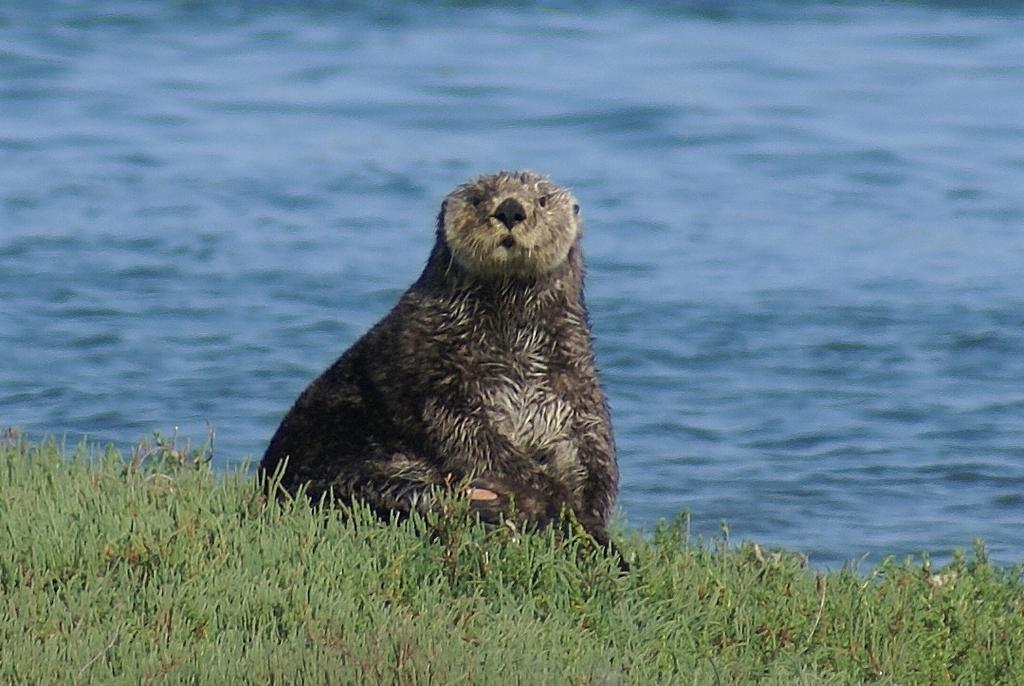What type of terrain is at the bottom of the image? There is grass at the bottom of the image. What animal can be seen in the middle of the image? There is a sea otter in the middle of the image. What can be seen in the background of the image? There is water visible in the background of the image. What type of advice can be seen written on the grass in the image? There is no advice written on the grass in the image; it is a natural terrain with no text or objects present. 